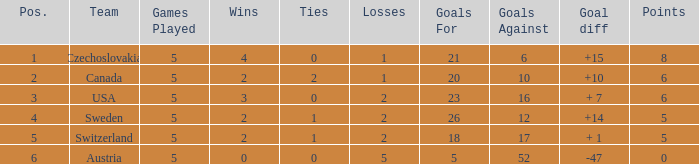What was the largest tie when the G.P was more than 5? None. 